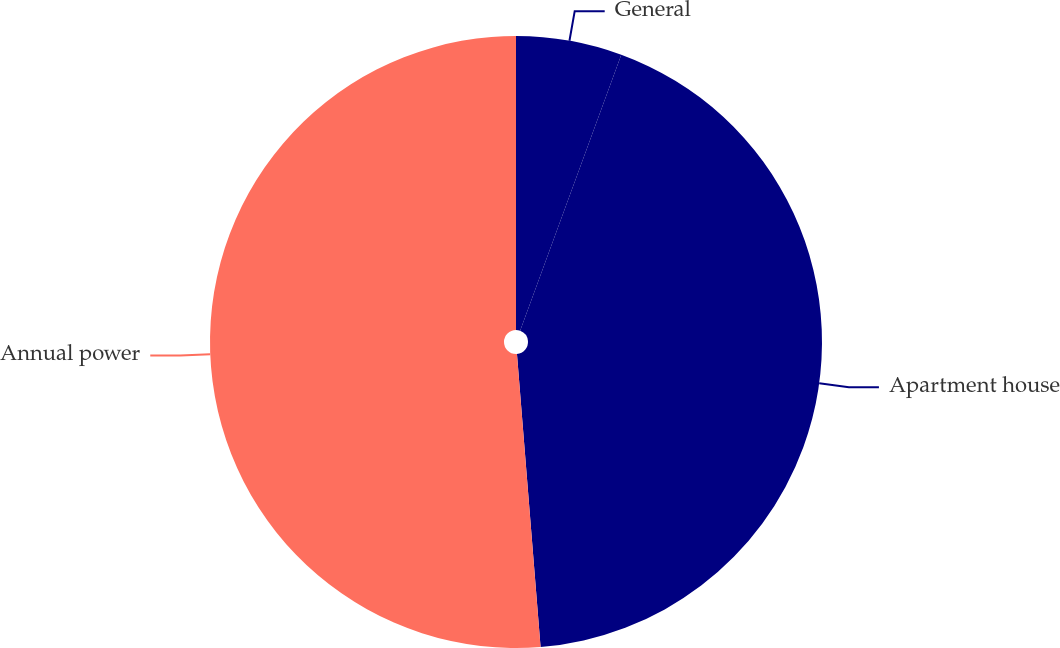<chart> <loc_0><loc_0><loc_500><loc_500><pie_chart><fcel>General<fcel>Apartment house<fcel>Annual power<nl><fcel>5.59%<fcel>43.13%<fcel>51.28%<nl></chart> 